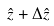<formula> <loc_0><loc_0><loc_500><loc_500>\hat { z } + \Delta \hat { z }</formula> 